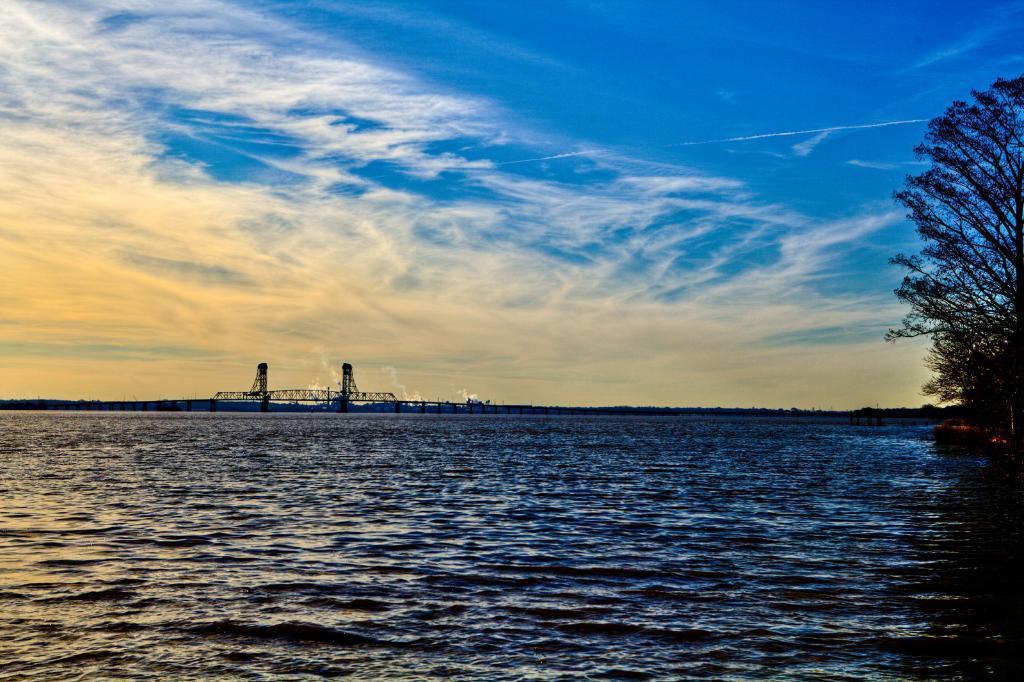In one or two sentences, can you explain what this image depicts? In this image at the bottom there is a river and on the right side there are trees. And in the background there are some towers, and at the top there is sky. 